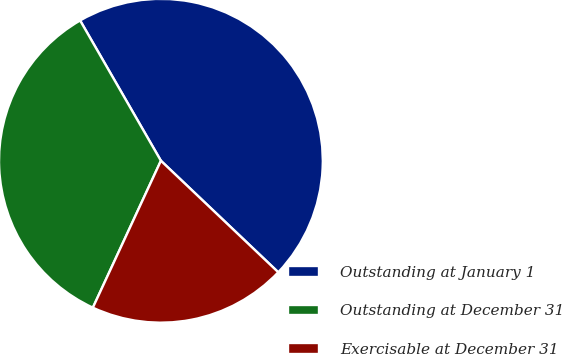Convert chart. <chart><loc_0><loc_0><loc_500><loc_500><pie_chart><fcel>Outstanding at January 1<fcel>Outstanding at December 31<fcel>Exercisable at December 31<nl><fcel>45.41%<fcel>34.78%<fcel>19.81%<nl></chart> 